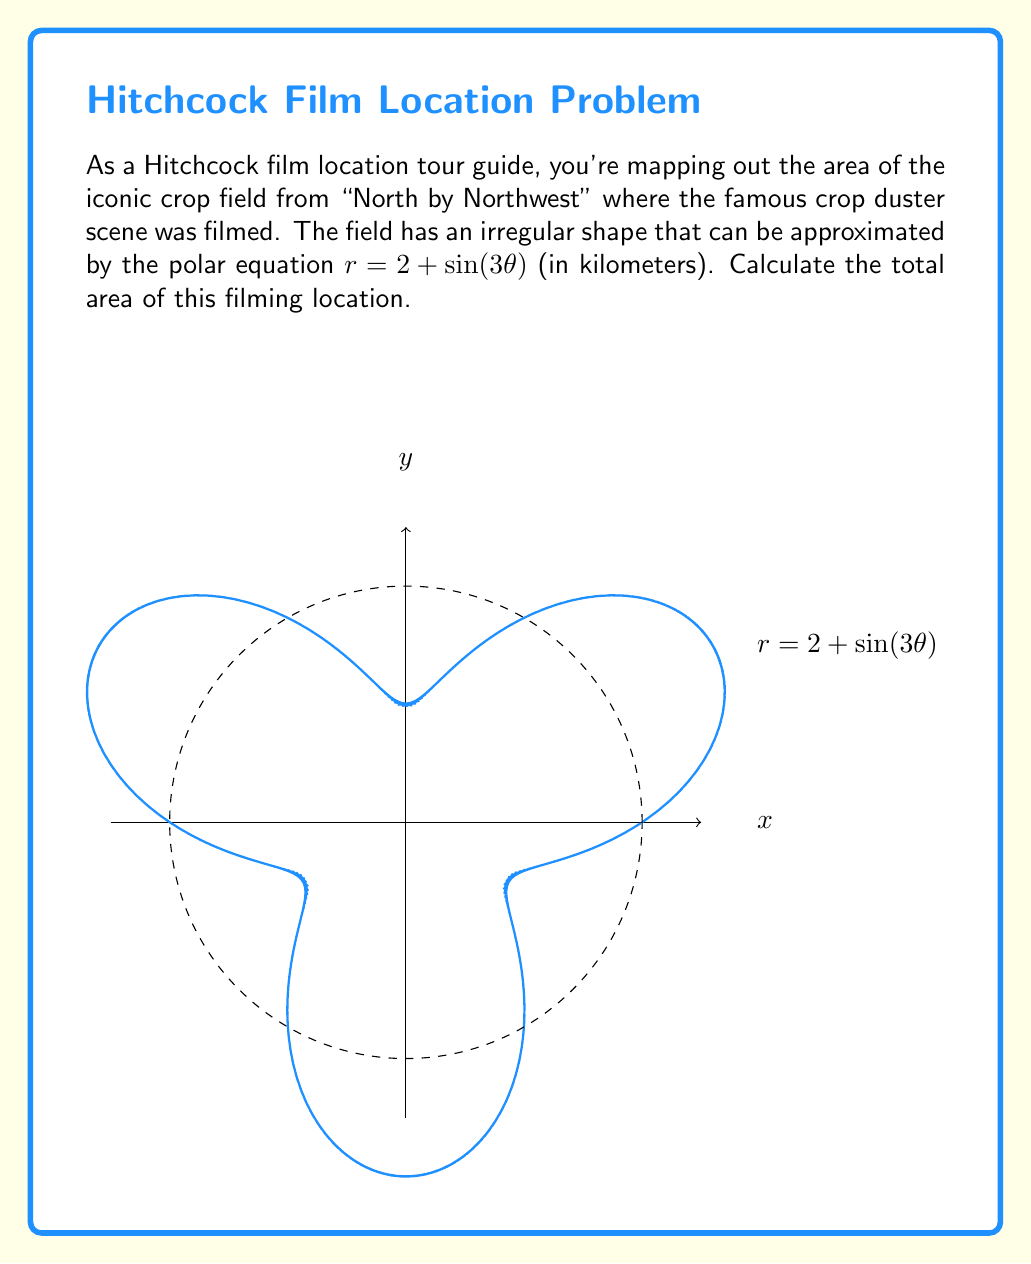Provide a solution to this math problem. To find the area of this irregularly shaped field, we need to use polar integration. The formula for the area of a region in polar coordinates is:

$$A = \frac{1}{2} \int_{0}^{2\pi} r^2(\theta) \, d\theta$$

Here's how we solve this step-by-step:

1) Our polar equation is $r = 2 + \sin(3\theta)$

2) We need to square this function:
   $r^2 = (2 + \sin(3\theta))^2 = 4 + 4\sin(3\theta) + \sin^2(3\theta)$

3) Now we set up our integral:
   $$A = \frac{1}{2} \int_{0}^{2\pi} (4 + 4\sin(3\theta) + \sin^2(3\theta)) \, d\theta$$

4) Let's integrate each term:
   - $\int_{0}^{2\pi} 4 \, d\theta = 4\theta \big|_{0}^{2\pi} = 8\pi$
   - $\int_{0}^{2\pi} 4\sin(3\theta) \, d\theta = -\frac{4}{3}\cos(3\theta) \big|_{0}^{2\pi} = 0$
   - $\int_{0}^{2\pi} \sin^2(3\theta) \, d\theta = \int_{0}^{2\pi} \frac{1-\cos(6\theta)}{2} \, d\theta = \frac{\theta}{2} - \frac{\sin(6\theta)}{12} \big|_{0}^{2\pi} = \pi$

5) Adding these results:
   $$A = \frac{1}{2}(8\pi + 0 + \pi) = \frac{9\pi}{2}$$

6) The area is in square kilometers, so our final answer is $\frac{9\pi}{2}$ km².
Answer: $\frac{9\pi}{2}$ km² 